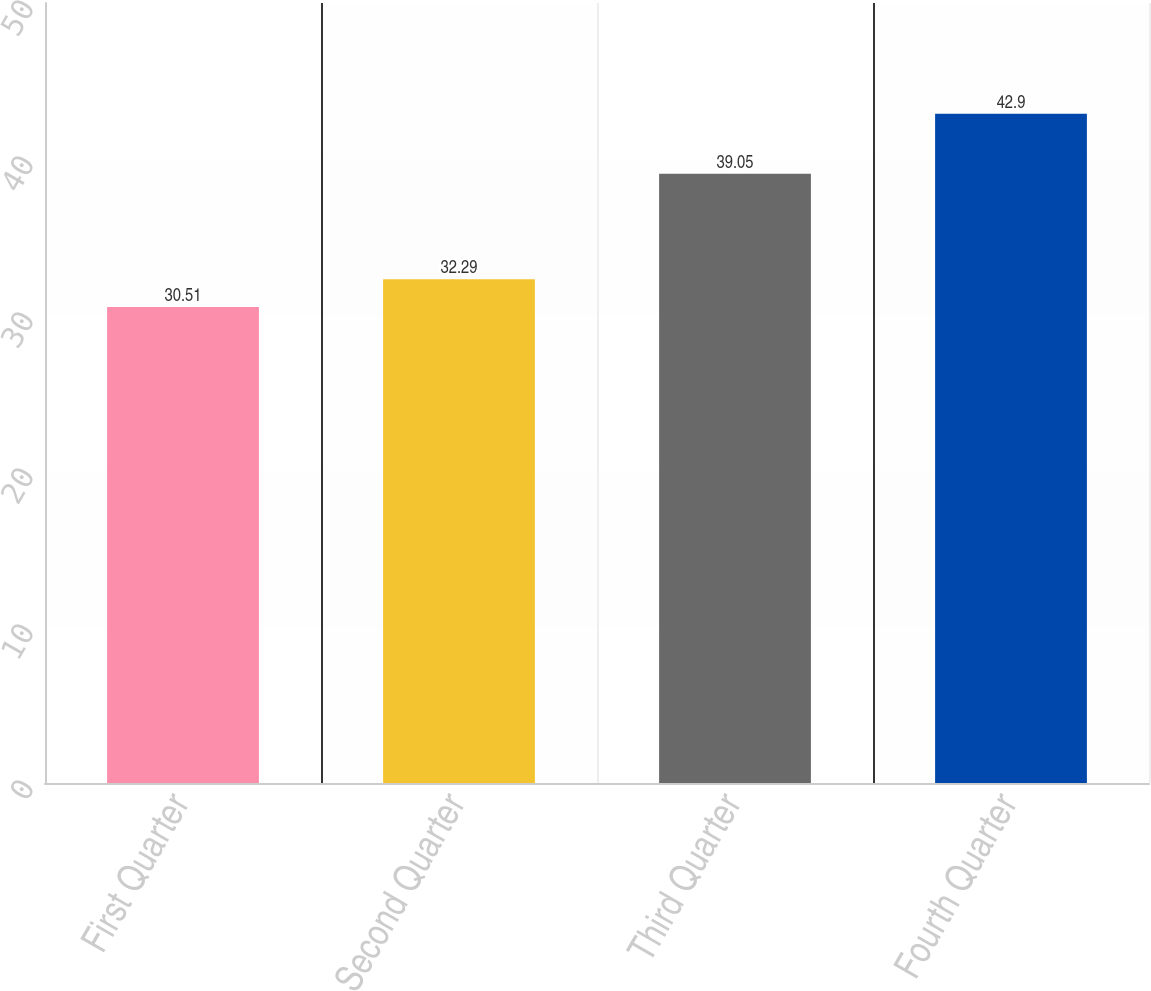Convert chart to OTSL. <chart><loc_0><loc_0><loc_500><loc_500><bar_chart><fcel>First Quarter<fcel>Second Quarter<fcel>Third Quarter<fcel>Fourth Quarter<nl><fcel>30.51<fcel>32.29<fcel>39.05<fcel>42.9<nl></chart> 